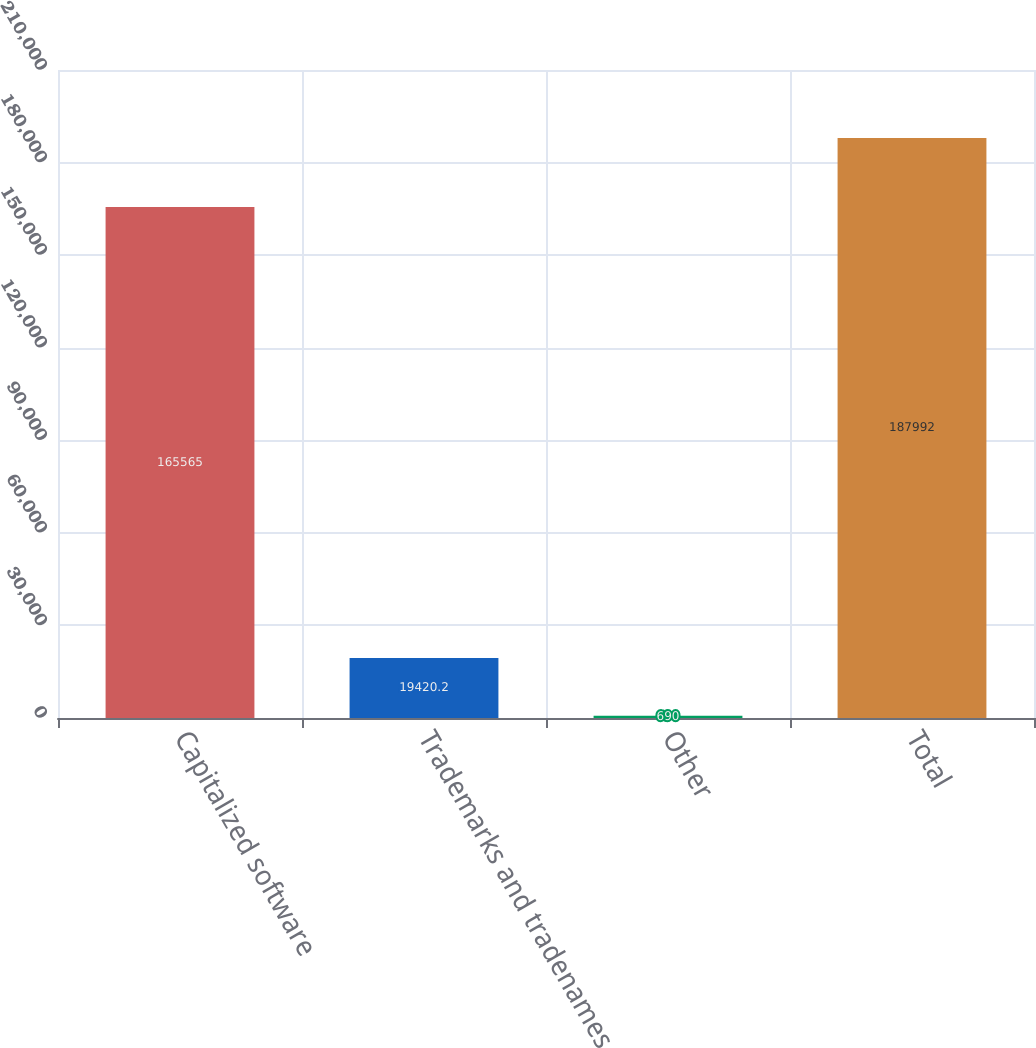<chart> <loc_0><loc_0><loc_500><loc_500><bar_chart><fcel>Capitalized software<fcel>Trademarks and tradenames<fcel>Other<fcel>Total<nl><fcel>165565<fcel>19420.2<fcel>690<fcel>187992<nl></chart> 